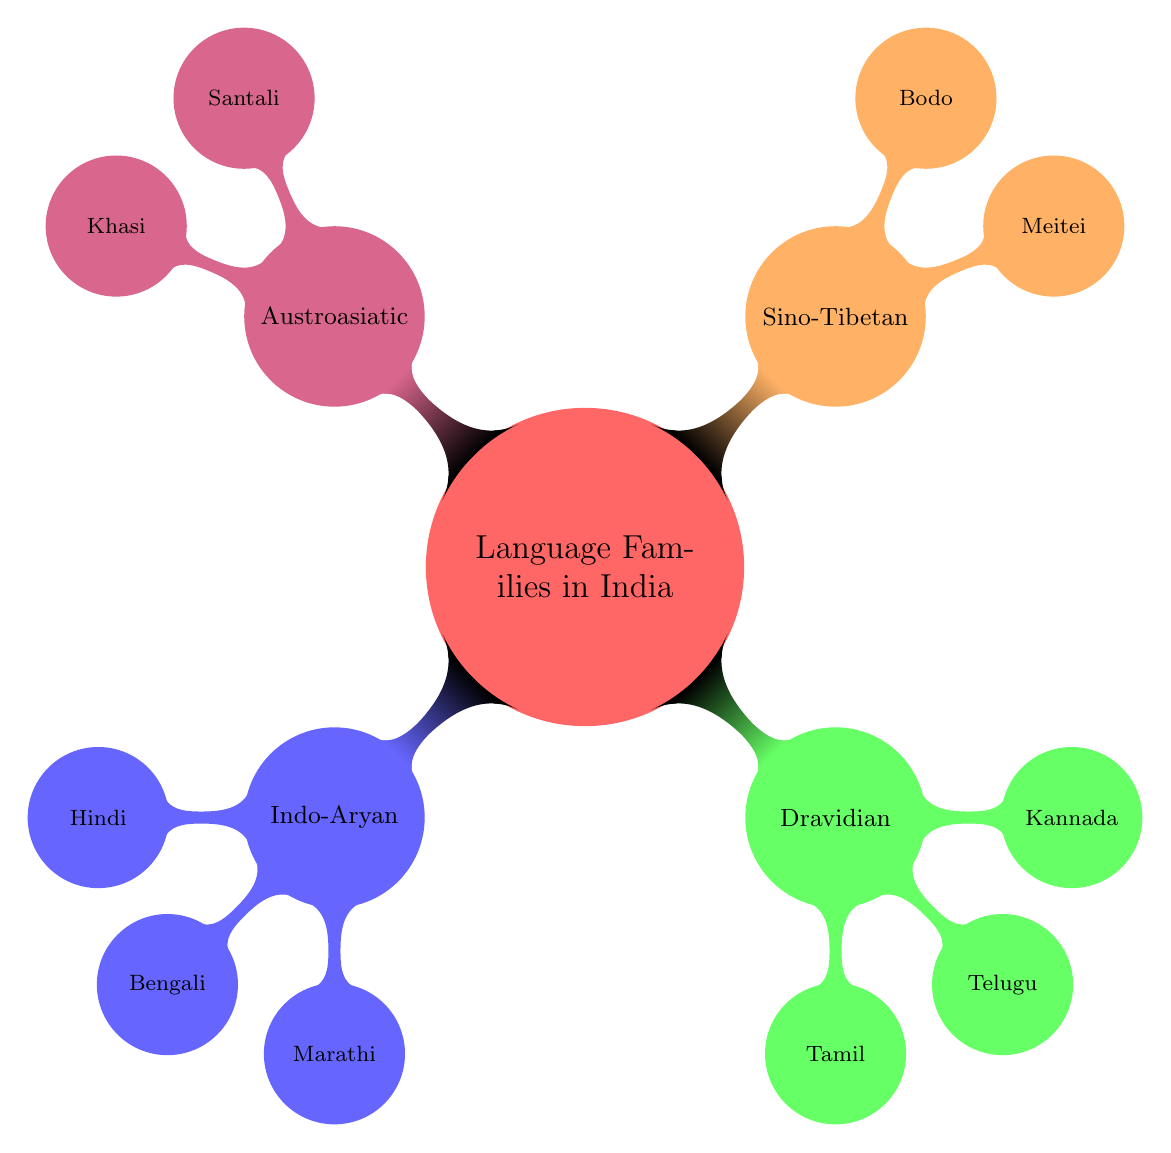What are the four main language families depicted? The mind map shows four main branches representing the language families which are Indo-Aryan, Dravidian, Sino-Tibetan, and Austroasiatic.
Answer: Indo-Aryan, Dravidian, Sino-Tibetan, Austroasiatic How many major languages are listed under the Dravidian family? Under the Dravidian branch, there are three major languages: Tamil, Telugu, and Kannada.
Answer: 3 Which language has the dialect of Khari Boli? In the Indo-Aryan family, Hindi has Khari Boli as one of its dialects.
Answer: Hindi Which language family does Santali belong to? Santali is listed under the Austroasiatic family in the mind map, indicating its classification.
Answer: Austroasiatic Name one major language that is categorized under the Sino-Tibetan family. The Sino-Tibetan family includes major languages like Meitei and Bodo. Listing any of these is a correct response.
Answer: Meitei Which two regions are associated with the geographic distribution of Bengali? Bengali is geographically distributed in West Bengal and Bangladesh, as indicated in the diagram.
Answer: West Bengal, Bangladesh What is the historical evolution start point for the Dravidian languages? The historical evolution of Dravidian languages begins with Proto-Dravidian, as shown in the mind map.
Answer: Proto-Dravidian How many dialects are associated with Tamil? Tamil has three dialects listed: Madurai Tamil, Kongu Tamil, and Jaffna Tamil, as per the diagram.
Answer: 3 Which language family has Meitei as a major language? Meitei is a major language under the Sino-Tibetan family, as illustrated in the mind map.
Answer: Sino-Tibetan Which dialect belongs to the Kannada language? The mind map shows several dialects under Kannada, such as Mysore Kannada, Havyaka Kannada, and Kundapura Kannada. Listing any of these would be correct.
Answer: Mysore Kannada 